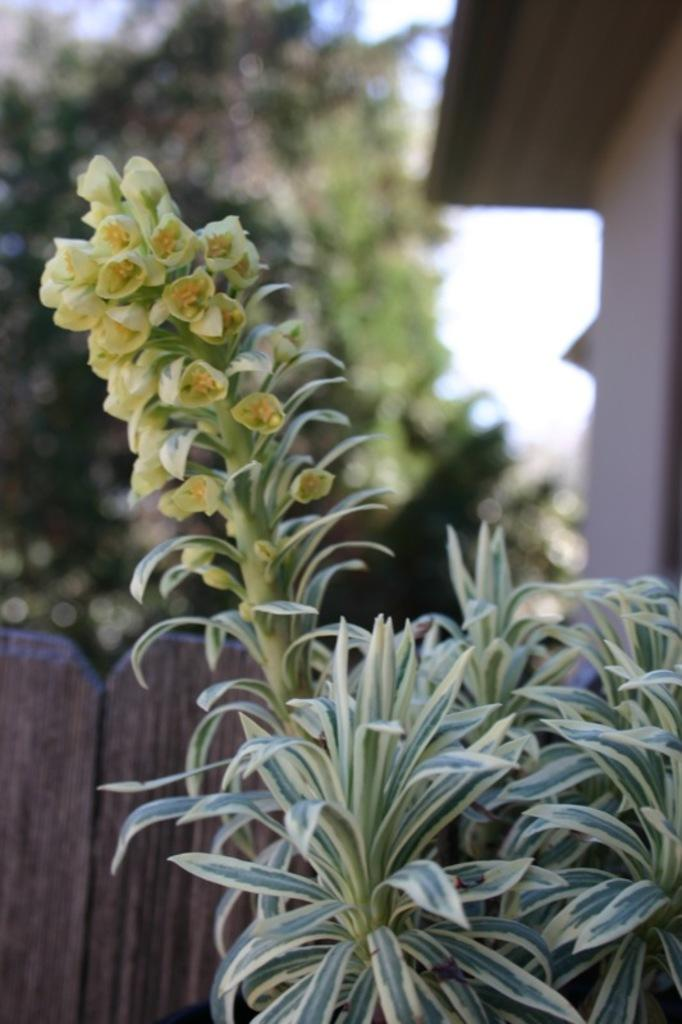What types of vegetation are in the foreground of the image? There are flowers and plants in the foreground of the image. What type of structure can be seen in the background of the image? There is a wooden fence in the background of the image. What other natural elements are visible in the background of the image? There are trees in the background of the image. What type of building is present in the background of the image? There is a house in the background of the image. How does the comb help the kettle in the image? There is no comb or kettle present in the image. 